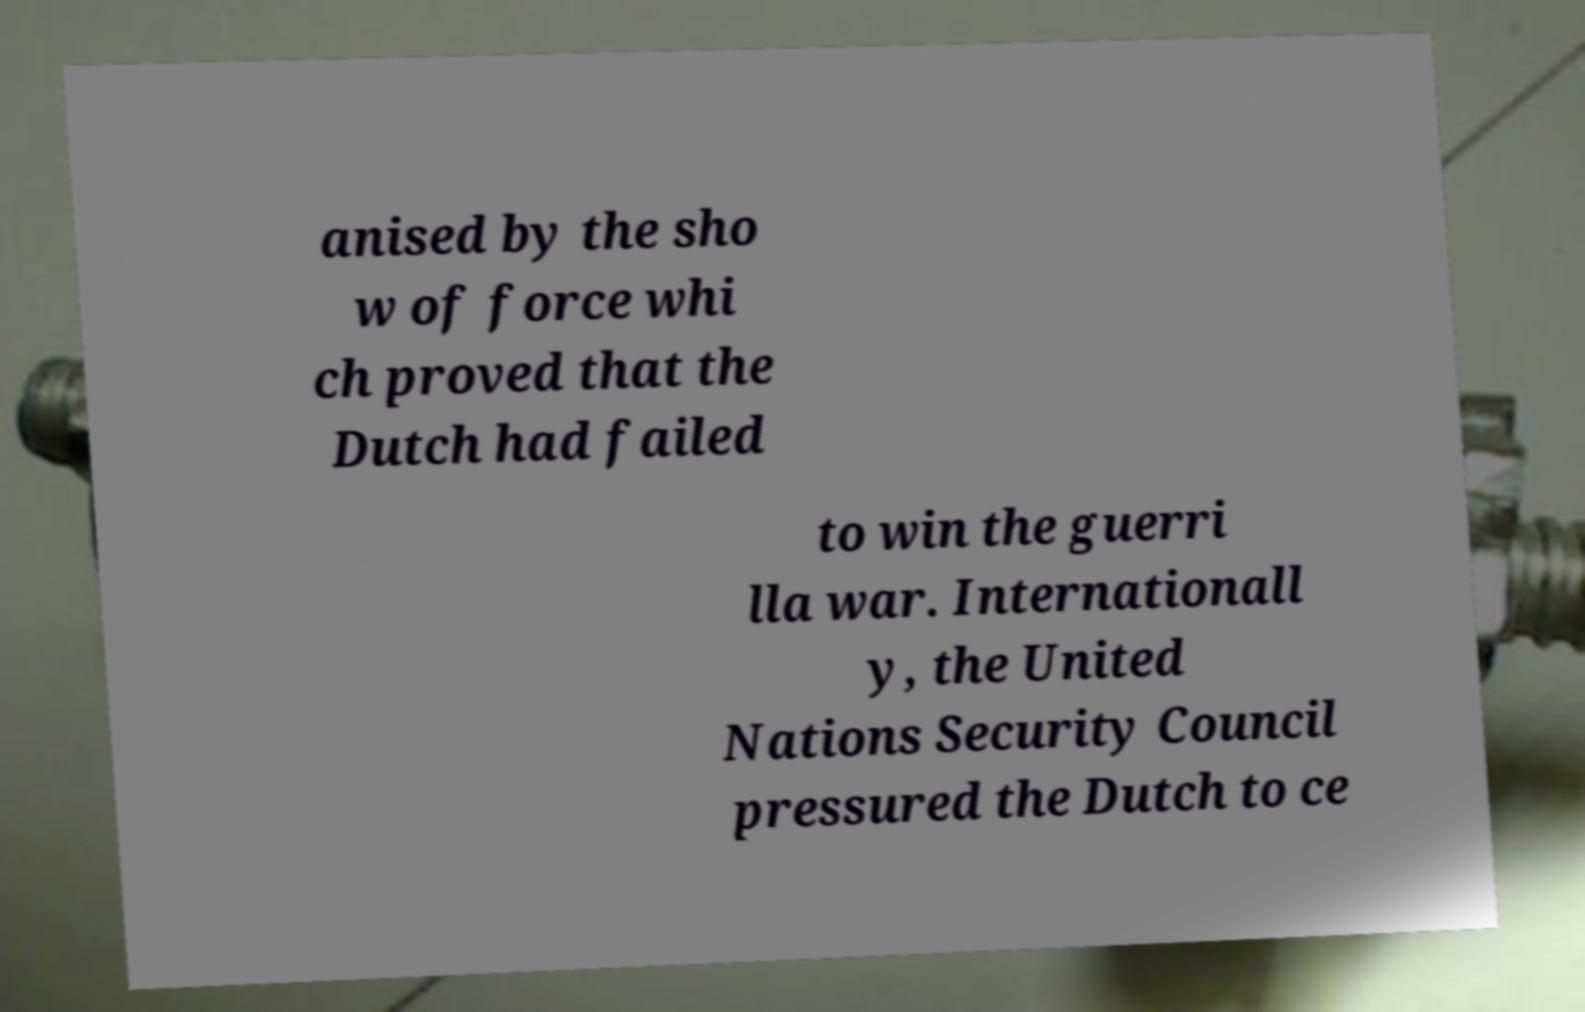Could you assist in decoding the text presented in this image and type it out clearly? anised by the sho w of force whi ch proved that the Dutch had failed to win the guerri lla war. Internationall y, the United Nations Security Council pressured the Dutch to ce 